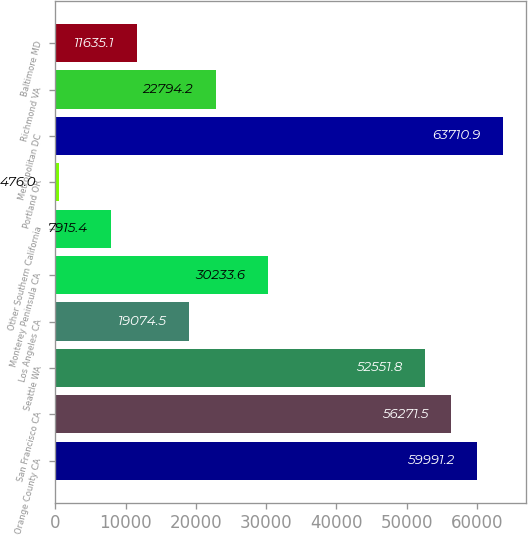Convert chart. <chart><loc_0><loc_0><loc_500><loc_500><bar_chart><fcel>Orange County CA<fcel>San Francisco CA<fcel>Seattle WA<fcel>Los Angeles CA<fcel>Monterey Peninsula CA<fcel>Other Southern California<fcel>Portland OR<fcel>Metropolitan DC<fcel>Richmond VA<fcel>Baltimore MD<nl><fcel>59991.2<fcel>56271.5<fcel>52551.8<fcel>19074.5<fcel>30233.6<fcel>7915.4<fcel>476<fcel>63710.9<fcel>22794.2<fcel>11635.1<nl></chart> 